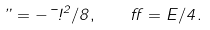Convert formula to latex. <formula><loc_0><loc_0><loc_500><loc_500>\varepsilon = - \mu \omega ^ { 2 } / 8 , \quad \alpha = E / 4 .</formula> 